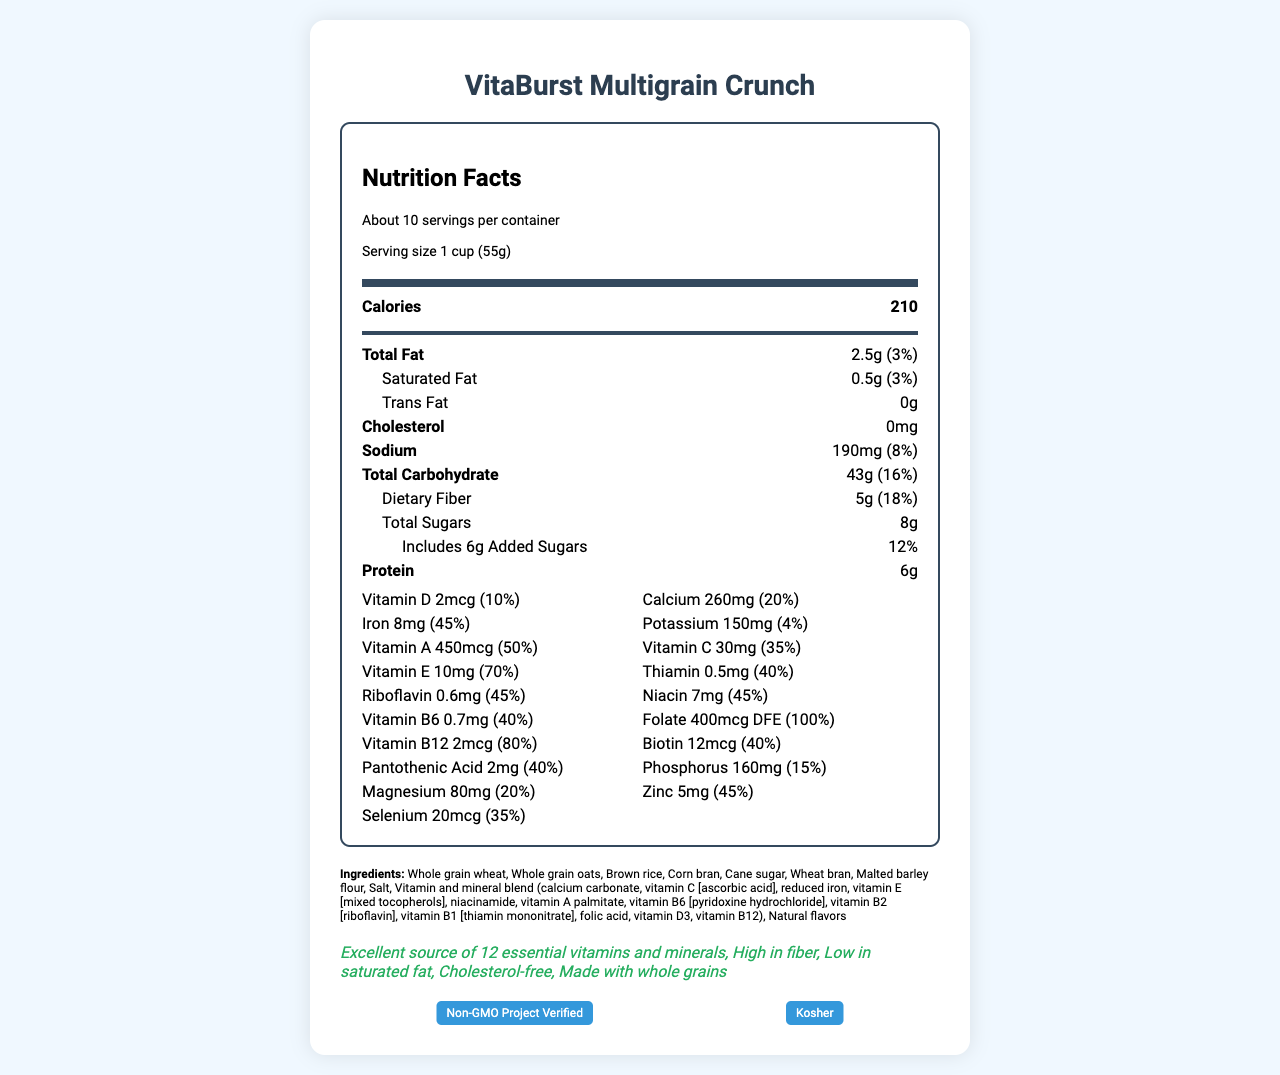what is the serving size of VitaBurst Multigrain Crunch? The serving size is explicitly mentioned in the document as "1 cup (55g)".
Answer: 1 cup (55g) How many calories are there per serving? The document states that each serving contains 210 calories.
Answer: 210 What percentage of the daily value of dietary fiber does VitaBurst provide per serving? The daily value percentage for dietary fiber is listed as 18%.
Answer: 18% How much iron is in one serving of VitaBurst Multigrain Crunch? The amount of iron per serving is given as 8mg.
Answer: 8mg Which vitamin is present at 50% of the daily value in this cereal? The document specifies that Vitamin A is present at 50% of the daily value.
Answer: Vitamin A What certifications does VitaBurst Multigrain Crunch have? A. USDA Organic B. Gluten-Free C. Non-GMO Project Verified D. Halal The document lists two certifications: "Non-GMO Project Verified" and "Kosher". Therefore, C is the correct answer.
Answer: C What is the allergen information provided for VitaBurst Multigrain Crunch? A. Contains soy B. May contain tree nuts C. Gluten-free D. Contains dairy The allergen information states that the product contains wheat ingredients and may contain traces of soy and tree nuts. Hence, B is part of the allergen warning.
Answer: B Is VitaBurst Multigrain Crunch cholesterol-free? The document explicitly states "Cholesterol: 0mg" indicating it is cholesterol-free.
Answer: Yes Summarize the main health claims made about VitaBurst Multigrain Crunch. The health claims in the document emphasize its nutritional benefits such as being rich in essential vitamins and minerals, high fiber content, low in saturated fat, cholesterol-free, and made with whole grains.
Answer: Excellent source of 12 essential vitamins and minerals, high in fiber, low in saturated fat, cholesterol-free, made with whole grains What is the product's expiration date? The document does not provide information regarding the expiration date. Therefore, the expiration date cannot be determined from the available information.
Answer: Not enough information How much added sugar is in each serving of the cereal? The document states that there are 6g of added sugars per serving.
Answer: 6g Which vitamin has the highest daily value percentage in VitaBurst Multigrain Crunch? A. Vitamin D B. Vitamin B12 C. Folate D. Zinc Folate has the highest daily value percentage at 100%, compared to the other vitamins listed.
Answer: C Is VitaBurst Multigrain Crunch suitable for vegans? The document doesn't specify whether the cereal is suitable for vegans. It only lists ingredients and certifications but does not mention vegan suitability.
Answer: Not enough information What is the amount of calcium provided by one serving of VitaBurst Multigrain Crunch? The document states that each serving contains 260mg of calcium.
Answer: 260mg Which ingredient is listed first in the ingredients list for VitaBurst Multigrain Crunch? The ingredients list starts with "Whole grain wheat".
Answer: Whole grain wheat What are the two main categories of vitamins and minerals listed in the document? The document explicitly mentions that the product is an "Excellent source of 12 essential vitamins and minerals".
Answer: Essential vitamins and minerals What is the daily value percentage for protein in one serving? The daily value percentage for protein is not provided in the document, only the amount (6g) is listed.
Answer: Not specified What should you do to maintain freshness after opening the package? The storage instructions mention to "Reseal package to maintain freshness".
Answer: Reseal the package Explain the certifications of VitaBurst Multigrain Crunch in terms of consumer trust. These certifications indicate the product meets certain standards, non-GMO verification assures the product does not contain genetically modified organisms, and Kosher certification implies it adheres to dietary laws respected by Kosher-keeping consumers, thus enhancing consumer trust.
Answer: VitaBurst is Non-GMO Project Verified and Kosher certified Is there any trans fat in one serving of VitaBurst Multigrain Crunch? The document specifies that the trans fat content is 0g.
Answer: No 